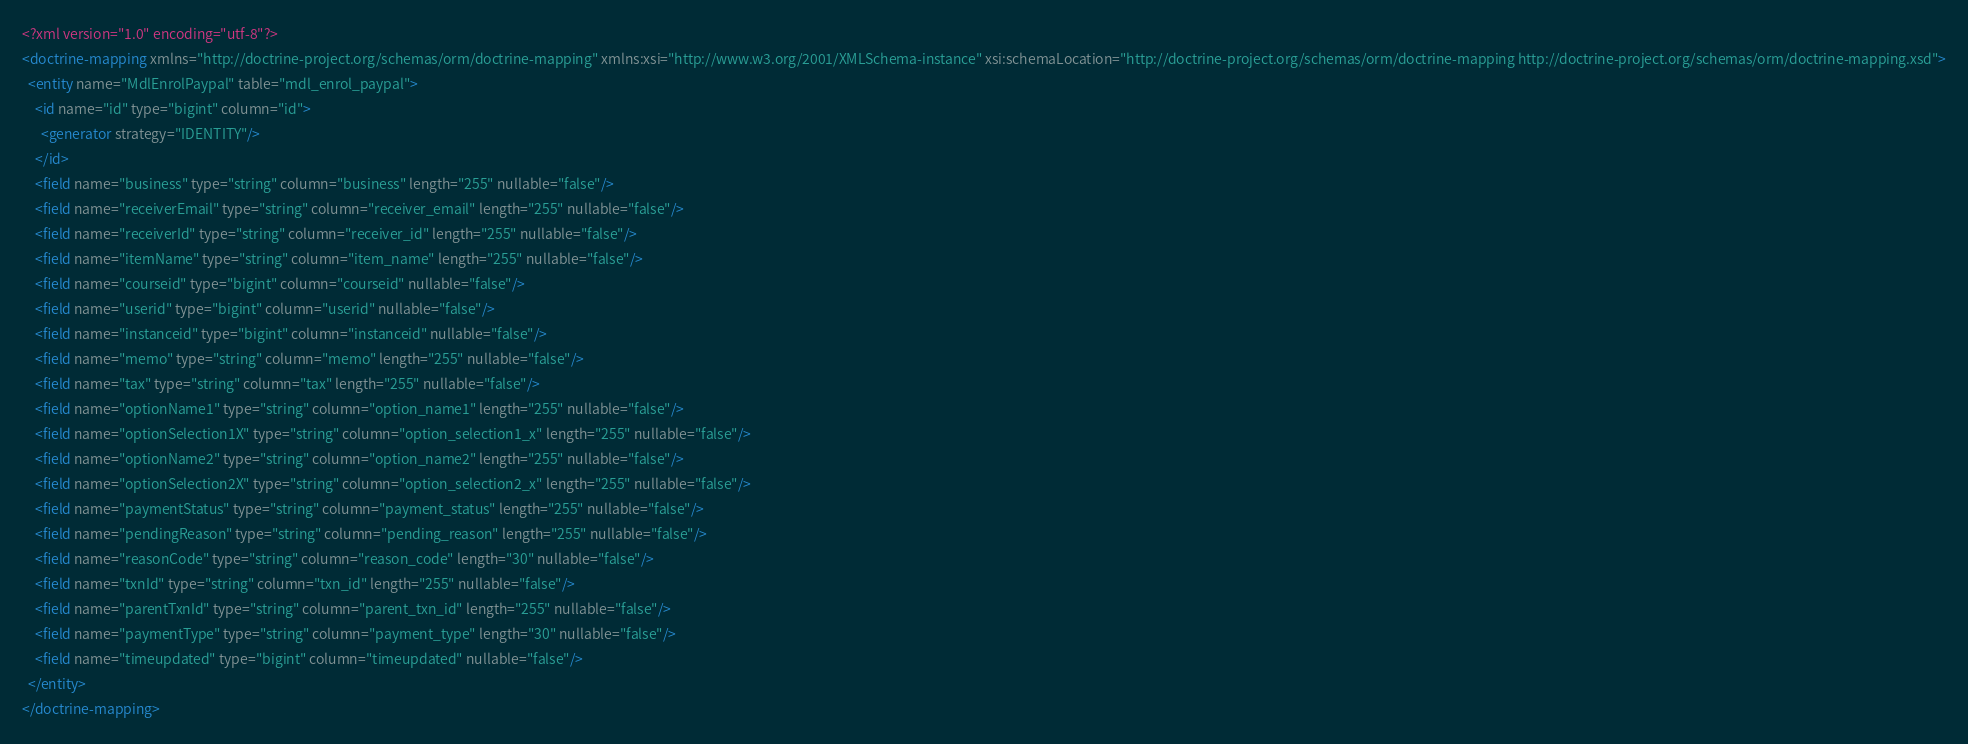Convert code to text. <code><loc_0><loc_0><loc_500><loc_500><_XML_><?xml version="1.0" encoding="utf-8"?>
<doctrine-mapping xmlns="http://doctrine-project.org/schemas/orm/doctrine-mapping" xmlns:xsi="http://www.w3.org/2001/XMLSchema-instance" xsi:schemaLocation="http://doctrine-project.org/schemas/orm/doctrine-mapping http://doctrine-project.org/schemas/orm/doctrine-mapping.xsd">
  <entity name="MdlEnrolPaypal" table="mdl_enrol_paypal">
    <id name="id" type="bigint" column="id">
      <generator strategy="IDENTITY"/>
    </id>
    <field name="business" type="string" column="business" length="255" nullable="false"/>
    <field name="receiverEmail" type="string" column="receiver_email" length="255" nullable="false"/>
    <field name="receiverId" type="string" column="receiver_id" length="255" nullable="false"/>
    <field name="itemName" type="string" column="item_name" length="255" nullable="false"/>
    <field name="courseid" type="bigint" column="courseid" nullable="false"/>
    <field name="userid" type="bigint" column="userid" nullable="false"/>
    <field name="instanceid" type="bigint" column="instanceid" nullable="false"/>
    <field name="memo" type="string" column="memo" length="255" nullable="false"/>
    <field name="tax" type="string" column="tax" length="255" nullable="false"/>
    <field name="optionName1" type="string" column="option_name1" length="255" nullable="false"/>
    <field name="optionSelection1X" type="string" column="option_selection1_x" length="255" nullable="false"/>
    <field name="optionName2" type="string" column="option_name2" length="255" nullable="false"/>
    <field name="optionSelection2X" type="string" column="option_selection2_x" length="255" nullable="false"/>
    <field name="paymentStatus" type="string" column="payment_status" length="255" nullable="false"/>
    <field name="pendingReason" type="string" column="pending_reason" length="255" nullable="false"/>
    <field name="reasonCode" type="string" column="reason_code" length="30" nullable="false"/>
    <field name="txnId" type="string" column="txn_id" length="255" nullable="false"/>
    <field name="parentTxnId" type="string" column="parent_txn_id" length="255" nullable="false"/>
    <field name="paymentType" type="string" column="payment_type" length="30" nullable="false"/>
    <field name="timeupdated" type="bigint" column="timeupdated" nullable="false"/>
  </entity>
</doctrine-mapping>
</code> 